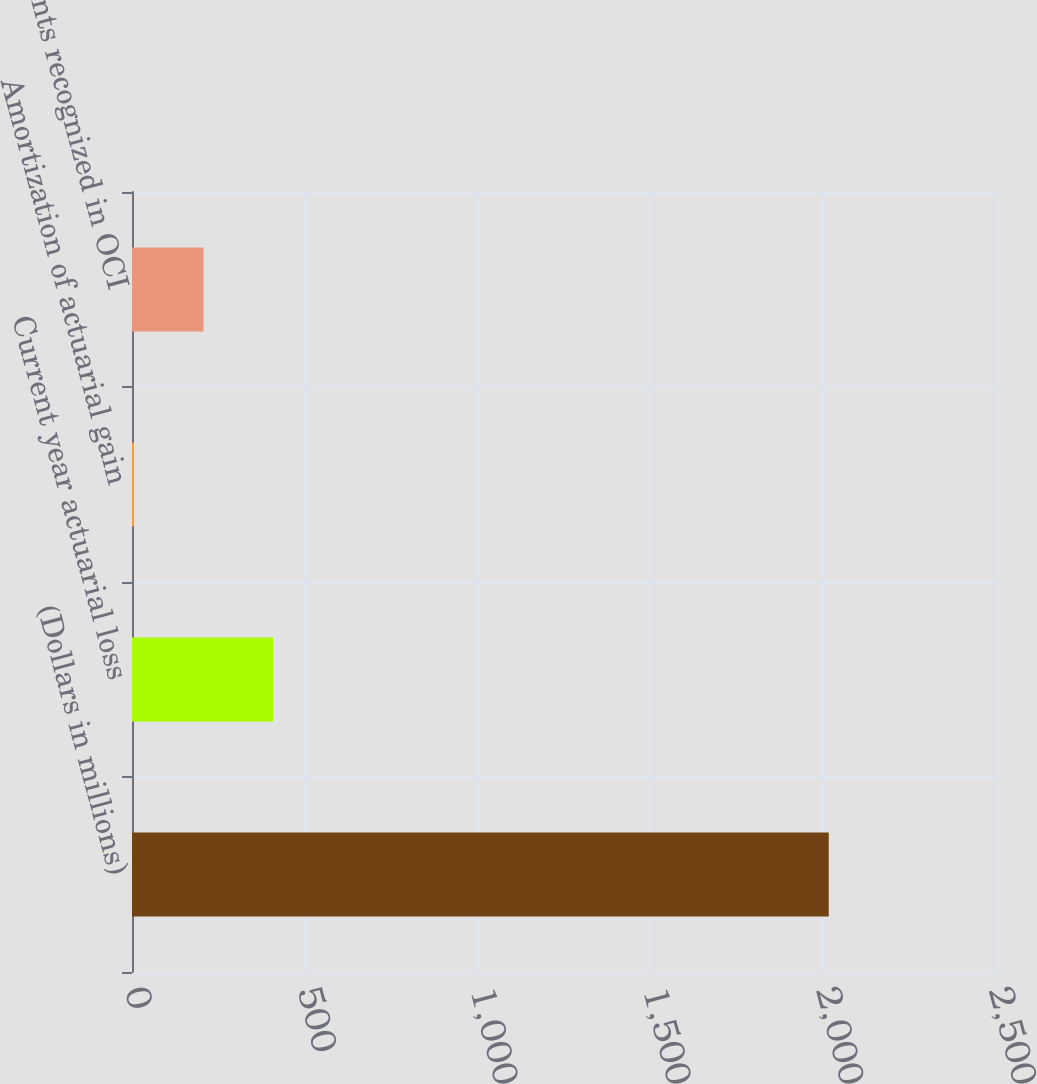Convert chart. <chart><loc_0><loc_0><loc_500><loc_500><bar_chart><fcel>(Dollars in millions)<fcel>Current year actuarial loss<fcel>Amortization of actuarial gain<fcel>Amounts recognized in OCI<nl><fcel>2016<fcel>408<fcel>6<fcel>207<nl></chart> 